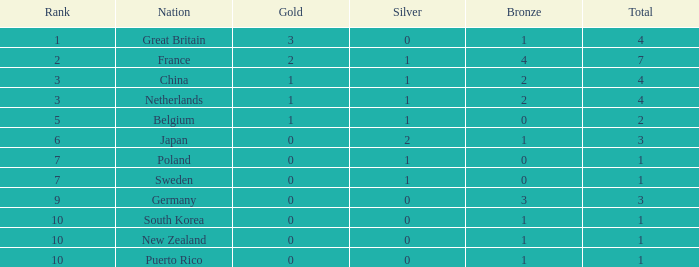What is the sum when the gold amount is greater than 2? 1.0. 